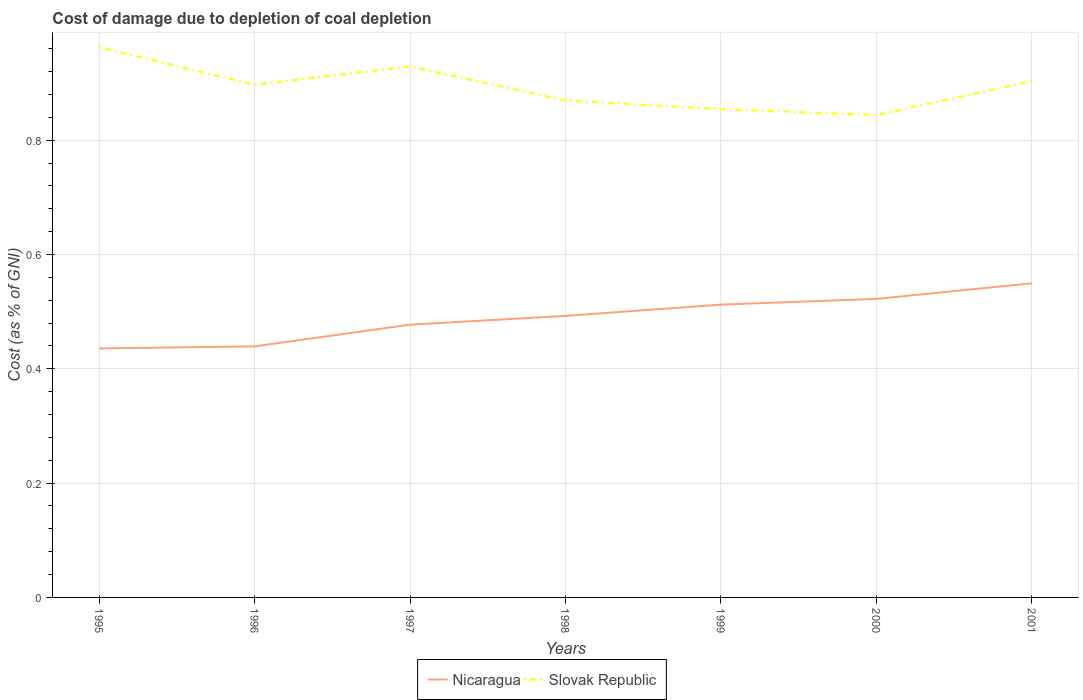Across all years, what is the maximum cost of damage caused due to coal depletion in Nicaragua?
Your response must be concise. 0.44. What is the total cost of damage caused due to coal depletion in Nicaragua in the graph?
Ensure brevity in your answer.  -0.05. What is the difference between the highest and the second highest cost of damage caused due to coal depletion in Nicaragua?
Provide a short and direct response. 0.11. What is the difference between the highest and the lowest cost of damage caused due to coal depletion in Slovak Republic?
Offer a very short reply. 4. Is the cost of damage caused due to coal depletion in Slovak Republic strictly greater than the cost of damage caused due to coal depletion in Nicaragua over the years?
Provide a succinct answer. No. How many lines are there?
Make the answer very short. 2. What is the difference between two consecutive major ticks on the Y-axis?
Offer a very short reply. 0.2. Are the values on the major ticks of Y-axis written in scientific E-notation?
Offer a terse response. No. Does the graph contain any zero values?
Your response must be concise. No. Does the graph contain grids?
Offer a terse response. Yes. What is the title of the graph?
Make the answer very short. Cost of damage due to depletion of coal depletion. Does "Vietnam" appear as one of the legend labels in the graph?
Offer a very short reply. No. What is the label or title of the Y-axis?
Offer a very short reply. Cost (as % of GNI). What is the Cost (as % of GNI) in Nicaragua in 1995?
Your answer should be compact. 0.44. What is the Cost (as % of GNI) in Slovak Republic in 1995?
Your answer should be very brief. 0.96. What is the Cost (as % of GNI) in Nicaragua in 1996?
Ensure brevity in your answer.  0.44. What is the Cost (as % of GNI) in Slovak Republic in 1996?
Give a very brief answer. 0.9. What is the Cost (as % of GNI) in Nicaragua in 1997?
Your response must be concise. 0.48. What is the Cost (as % of GNI) in Slovak Republic in 1997?
Offer a terse response. 0.93. What is the Cost (as % of GNI) in Nicaragua in 1998?
Your response must be concise. 0.49. What is the Cost (as % of GNI) of Slovak Republic in 1998?
Make the answer very short. 0.87. What is the Cost (as % of GNI) in Nicaragua in 1999?
Provide a succinct answer. 0.51. What is the Cost (as % of GNI) in Slovak Republic in 1999?
Your answer should be compact. 0.85. What is the Cost (as % of GNI) in Nicaragua in 2000?
Your answer should be very brief. 0.52. What is the Cost (as % of GNI) of Slovak Republic in 2000?
Offer a very short reply. 0.84. What is the Cost (as % of GNI) in Nicaragua in 2001?
Provide a short and direct response. 0.55. What is the Cost (as % of GNI) in Slovak Republic in 2001?
Provide a short and direct response. 0.9. Across all years, what is the maximum Cost (as % of GNI) in Nicaragua?
Your answer should be very brief. 0.55. Across all years, what is the maximum Cost (as % of GNI) in Slovak Republic?
Your answer should be very brief. 0.96. Across all years, what is the minimum Cost (as % of GNI) in Nicaragua?
Your answer should be compact. 0.44. Across all years, what is the minimum Cost (as % of GNI) of Slovak Republic?
Your response must be concise. 0.84. What is the total Cost (as % of GNI) of Nicaragua in the graph?
Provide a succinct answer. 3.43. What is the total Cost (as % of GNI) in Slovak Republic in the graph?
Your answer should be very brief. 6.26. What is the difference between the Cost (as % of GNI) in Nicaragua in 1995 and that in 1996?
Provide a succinct answer. -0. What is the difference between the Cost (as % of GNI) of Slovak Republic in 1995 and that in 1996?
Your answer should be very brief. 0.07. What is the difference between the Cost (as % of GNI) of Nicaragua in 1995 and that in 1997?
Your answer should be very brief. -0.04. What is the difference between the Cost (as % of GNI) in Slovak Republic in 1995 and that in 1997?
Your answer should be very brief. 0.03. What is the difference between the Cost (as % of GNI) of Nicaragua in 1995 and that in 1998?
Make the answer very short. -0.06. What is the difference between the Cost (as % of GNI) of Slovak Republic in 1995 and that in 1998?
Your response must be concise. 0.09. What is the difference between the Cost (as % of GNI) of Nicaragua in 1995 and that in 1999?
Your answer should be very brief. -0.08. What is the difference between the Cost (as % of GNI) of Slovak Republic in 1995 and that in 1999?
Provide a short and direct response. 0.11. What is the difference between the Cost (as % of GNI) in Nicaragua in 1995 and that in 2000?
Give a very brief answer. -0.09. What is the difference between the Cost (as % of GNI) of Slovak Republic in 1995 and that in 2000?
Offer a very short reply. 0.12. What is the difference between the Cost (as % of GNI) of Nicaragua in 1995 and that in 2001?
Offer a very short reply. -0.11. What is the difference between the Cost (as % of GNI) in Slovak Republic in 1995 and that in 2001?
Provide a short and direct response. 0.06. What is the difference between the Cost (as % of GNI) in Nicaragua in 1996 and that in 1997?
Keep it short and to the point. -0.04. What is the difference between the Cost (as % of GNI) in Slovak Republic in 1996 and that in 1997?
Offer a terse response. -0.03. What is the difference between the Cost (as % of GNI) in Nicaragua in 1996 and that in 1998?
Provide a succinct answer. -0.05. What is the difference between the Cost (as % of GNI) in Slovak Republic in 1996 and that in 1998?
Offer a terse response. 0.03. What is the difference between the Cost (as % of GNI) of Nicaragua in 1996 and that in 1999?
Your answer should be very brief. -0.07. What is the difference between the Cost (as % of GNI) of Slovak Republic in 1996 and that in 1999?
Ensure brevity in your answer.  0.04. What is the difference between the Cost (as % of GNI) of Nicaragua in 1996 and that in 2000?
Make the answer very short. -0.08. What is the difference between the Cost (as % of GNI) of Slovak Republic in 1996 and that in 2000?
Offer a terse response. 0.05. What is the difference between the Cost (as % of GNI) in Nicaragua in 1996 and that in 2001?
Your answer should be very brief. -0.11. What is the difference between the Cost (as % of GNI) of Slovak Republic in 1996 and that in 2001?
Your response must be concise. -0.01. What is the difference between the Cost (as % of GNI) of Nicaragua in 1997 and that in 1998?
Your answer should be very brief. -0.02. What is the difference between the Cost (as % of GNI) in Slovak Republic in 1997 and that in 1998?
Make the answer very short. 0.06. What is the difference between the Cost (as % of GNI) in Nicaragua in 1997 and that in 1999?
Make the answer very short. -0.04. What is the difference between the Cost (as % of GNI) of Slovak Republic in 1997 and that in 1999?
Offer a terse response. 0.07. What is the difference between the Cost (as % of GNI) in Nicaragua in 1997 and that in 2000?
Your answer should be very brief. -0.05. What is the difference between the Cost (as % of GNI) of Slovak Republic in 1997 and that in 2000?
Offer a very short reply. 0.09. What is the difference between the Cost (as % of GNI) of Nicaragua in 1997 and that in 2001?
Offer a very short reply. -0.07. What is the difference between the Cost (as % of GNI) in Slovak Republic in 1997 and that in 2001?
Ensure brevity in your answer.  0.03. What is the difference between the Cost (as % of GNI) of Nicaragua in 1998 and that in 1999?
Make the answer very short. -0.02. What is the difference between the Cost (as % of GNI) in Slovak Republic in 1998 and that in 1999?
Provide a succinct answer. 0.02. What is the difference between the Cost (as % of GNI) of Nicaragua in 1998 and that in 2000?
Offer a terse response. -0.03. What is the difference between the Cost (as % of GNI) of Slovak Republic in 1998 and that in 2000?
Offer a terse response. 0.03. What is the difference between the Cost (as % of GNI) in Nicaragua in 1998 and that in 2001?
Make the answer very short. -0.06. What is the difference between the Cost (as % of GNI) of Slovak Republic in 1998 and that in 2001?
Give a very brief answer. -0.03. What is the difference between the Cost (as % of GNI) of Nicaragua in 1999 and that in 2000?
Ensure brevity in your answer.  -0.01. What is the difference between the Cost (as % of GNI) of Slovak Republic in 1999 and that in 2000?
Offer a terse response. 0.01. What is the difference between the Cost (as % of GNI) in Nicaragua in 1999 and that in 2001?
Keep it short and to the point. -0.04. What is the difference between the Cost (as % of GNI) in Slovak Republic in 1999 and that in 2001?
Offer a terse response. -0.05. What is the difference between the Cost (as % of GNI) in Nicaragua in 2000 and that in 2001?
Your answer should be very brief. -0.03. What is the difference between the Cost (as % of GNI) of Slovak Republic in 2000 and that in 2001?
Your answer should be very brief. -0.06. What is the difference between the Cost (as % of GNI) in Nicaragua in 1995 and the Cost (as % of GNI) in Slovak Republic in 1996?
Offer a very short reply. -0.46. What is the difference between the Cost (as % of GNI) of Nicaragua in 1995 and the Cost (as % of GNI) of Slovak Republic in 1997?
Keep it short and to the point. -0.49. What is the difference between the Cost (as % of GNI) in Nicaragua in 1995 and the Cost (as % of GNI) in Slovak Republic in 1998?
Provide a succinct answer. -0.43. What is the difference between the Cost (as % of GNI) in Nicaragua in 1995 and the Cost (as % of GNI) in Slovak Republic in 1999?
Provide a short and direct response. -0.42. What is the difference between the Cost (as % of GNI) in Nicaragua in 1995 and the Cost (as % of GNI) in Slovak Republic in 2000?
Keep it short and to the point. -0.41. What is the difference between the Cost (as % of GNI) of Nicaragua in 1995 and the Cost (as % of GNI) of Slovak Republic in 2001?
Your response must be concise. -0.47. What is the difference between the Cost (as % of GNI) in Nicaragua in 1996 and the Cost (as % of GNI) in Slovak Republic in 1997?
Make the answer very short. -0.49. What is the difference between the Cost (as % of GNI) of Nicaragua in 1996 and the Cost (as % of GNI) of Slovak Republic in 1998?
Your answer should be very brief. -0.43. What is the difference between the Cost (as % of GNI) in Nicaragua in 1996 and the Cost (as % of GNI) in Slovak Republic in 1999?
Make the answer very short. -0.41. What is the difference between the Cost (as % of GNI) in Nicaragua in 1996 and the Cost (as % of GNI) in Slovak Republic in 2000?
Offer a very short reply. -0.4. What is the difference between the Cost (as % of GNI) of Nicaragua in 1996 and the Cost (as % of GNI) of Slovak Republic in 2001?
Your answer should be very brief. -0.46. What is the difference between the Cost (as % of GNI) of Nicaragua in 1997 and the Cost (as % of GNI) of Slovak Republic in 1998?
Keep it short and to the point. -0.39. What is the difference between the Cost (as % of GNI) of Nicaragua in 1997 and the Cost (as % of GNI) of Slovak Republic in 1999?
Your response must be concise. -0.38. What is the difference between the Cost (as % of GNI) in Nicaragua in 1997 and the Cost (as % of GNI) in Slovak Republic in 2000?
Keep it short and to the point. -0.37. What is the difference between the Cost (as % of GNI) of Nicaragua in 1997 and the Cost (as % of GNI) of Slovak Republic in 2001?
Give a very brief answer. -0.43. What is the difference between the Cost (as % of GNI) in Nicaragua in 1998 and the Cost (as % of GNI) in Slovak Republic in 1999?
Your answer should be very brief. -0.36. What is the difference between the Cost (as % of GNI) in Nicaragua in 1998 and the Cost (as % of GNI) in Slovak Republic in 2000?
Your response must be concise. -0.35. What is the difference between the Cost (as % of GNI) in Nicaragua in 1998 and the Cost (as % of GNI) in Slovak Republic in 2001?
Provide a succinct answer. -0.41. What is the difference between the Cost (as % of GNI) in Nicaragua in 1999 and the Cost (as % of GNI) in Slovak Republic in 2000?
Provide a short and direct response. -0.33. What is the difference between the Cost (as % of GNI) in Nicaragua in 1999 and the Cost (as % of GNI) in Slovak Republic in 2001?
Your response must be concise. -0.39. What is the difference between the Cost (as % of GNI) of Nicaragua in 2000 and the Cost (as % of GNI) of Slovak Republic in 2001?
Make the answer very short. -0.38. What is the average Cost (as % of GNI) in Nicaragua per year?
Give a very brief answer. 0.49. What is the average Cost (as % of GNI) in Slovak Republic per year?
Provide a succinct answer. 0.89. In the year 1995, what is the difference between the Cost (as % of GNI) of Nicaragua and Cost (as % of GNI) of Slovak Republic?
Offer a terse response. -0.53. In the year 1996, what is the difference between the Cost (as % of GNI) in Nicaragua and Cost (as % of GNI) in Slovak Republic?
Keep it short and to the point. -0.46. In the year 1997, what is the difference between the Cost (as % of GNI) of Nicaragua and Cost (as % of GNI) of Slovak Republic?
Offer a terse response. -0.45. In the year 1998, what is the difference between the Cost (as % of GNI) of Nicaragua and Cost (as % of GNI) of Slovak Republic?
Provide a succinct answer. -0.38. In the year 1999, what is the difference between the Cost (as % of GNI) of Nicaragua and Cost (as % of GNI) of Slovak Republic?
Provide a short and direct response. -0.34. In the year 2000, what is the difference between the Cost (as % of GNI) of Nicaragua and Cost (as % of GNI) of Slovak Republic?
Give a very brief answer. -0.32. In the year 2001, what is the difference between the Cost (as % of GNI) in Nicaragua and Cost (as % of GNI) in Slovak Republic?
Make the answer very short. -0.35. What is the ratio of the Cost (as % of GNI) in Nicaragua in 1995 to that in 1996?
Provide a succinct answer. 0.99. What is the ratio of the Cost (as % of GNI) in Slovak Republic in 1995 to that in 1996?
Give a very brief answer. 1.07. What is the ratio of the Cost (as % of GNI) of Nicaragua in 1995 to that in 1997?
Your answer should be very brief. 0.91. What is the ratio of the Cost (as % of GNI) of Slovak Republic in 1995 to that in 1997?
Your answer should be compact. 1.04. What is the ratio of the Cost (as % of GNI) of Nicaragua in 1995 to that in 1998?
Make the answer very short. 0.88. What is the ratio of the Cost (as % of GNI) in Slovak Republic in 1995 to that in 1998?
Your response must be concise. 1.11. What is the ratio of the Cost (as % of GNI) of Nicaragua in 1995 to that in 1999?
Your response must be concise. 0.85. What is the ratio of the Cost (as % of GNI) in Slovak Republic in 1995 to that in 1999?
Offer a terse response. 1.13. What is the ratio of the Cost (as % of GNI) in Nicaragua in 1995 to that in 2000?
Ensure brevity in your answer.  0.83. What is the ratio of the Cost (as % of GNI) of Slovak Republic in 1995 to that in 2000?
Your response must be concise. 1.14. What is the ratio of the Cost (as % of GNI) in Nicaragua in 1995 to that in 2001?
Provide a succinct answer. 0.79. What is the ratio of the Cost (as % of GNI) of Slovak Republic in 1995 to that in 2001?
Your answer should be very brief. 1.07. What is the ratio of the Cost (as % of GNI) in Nicaragua in 1996 to that in 1997?
Provide a succinct answer. 0.92. What is the ratio of the Cost (as % of GNI) of Slovak Republic in 1996 to that in 1997?
Make the answer very short. 0.97. What is the ratio of the Cost (as % of GNI) in Nicaragua in 1996 to that in 1998?
Make the answer very short. 0.89. What is the ratio of the Cost (as % of GNI) in Slovak Republic in 1996 to that in 1998?
Give a very brief answer. 1.03. What is the ratio of the Cost (as % of GNI) of Nicaragua in 1996 to that in 1999?
Your answer should be very brief. 0.86. What is the ratio of the Cost (as % of GNI) of Slovak Republic in 1996 to that in 1999?
Offer a terse response. 1.05. What is the ratio of the Cost (as % of GNI) in Nicaragua in 1996 to that in 2000?
Ensure brevity in your answer.  0.84. What is the ratio of the Cost (as % of GNI) in Slovak Republic in 1996 to that in 2000?
Your answer should be very brief. 1.06. What is the ratio of the Cost (as % of GNI) of Nicaragua in 1996 to that in 2001?
Ensure brevity in your answer.  0.8. What is the ratio of the Cost (as % of GNI) of Slovak Republic in 1996 to that in 2001?
Your answer should be very brief. 0.99. What is the ratio of the Cost (as % of GNI) of Nicaragua in 1997 to that in 1998?
Offer a very short reply. 0.97. What is the ratio of the Cost (as % of GNI) of Slovak Republic in 1997 to that in 1998?
Make the answer very short. 1.07. What is the ratio of the Cost (as % of GNI) of Nicaragua in 1997 to that in 1999?
Your answer should be compact. 0.93. What is the ratio of the Cost (as % of GNI) of Slovak Republic in 1997 to that in 1999?
Give a very brief answer. 1.09. What is the ratio of the Cost (as % of GNI) of Nicaragua in 1997 to that in 2000?
Your answer should be compact. 0.91. What is the ratio of the Cost (as % of GNI) in Slovak Republic in 1997 to that in 2000?
Provide a short and direct response. 1.1. What is the ratio of the Cost (as % of GNI) of Nicaragua in 1997 to that in 2001?
Provide a short and direct response. 0.87. What is the ratio of the Cost (as % of GNI) of Slovak Republic in 1997 to that in 2001?
Make the answer very short. 1.03. What is the ratio of the Cost (as % of GNI) in Nicaragua in 1998 to that in 1999?
Give a very brief answer. 0.96. What is the ratio of the Cost (as % of GNI) of Slovak Republic in 1998 to that in 1999?
Your answer should be compact. 1.02. What is the ratio of the Cost (as % of GNI) in Nicaragua in 1998 to that in 2000?
Keep it short and to the point. 0.94. What is the ratio of the Cost (as % of GNI) of Slovak Republic in 1998 to that in 2000?
Ensure brevity in your answer.  1.03. What is the ratio of the Cost (as % of GNI) of Nicaragua in 1998 to that in 2001?
Offer a terse response. 0.9. What is the ratio of the Cost (as % of GNI) in Slovak Republic in 1998 to that in 2001?
Give a very brief answer. 0.96. What is the ratio of the Cost (as % of GNI) of Nicaragua in 1999 to that in 2000?
Make the answer very short. 0.98. What is the ratio of the Cost (as % of GNI) of Slovak Republic in 1999 to that in 2000?
Offer a terse response. 1.01. What is the ratio of the Cost (as % of GNI) in Nicaragua in 1999 to that in 2001?
Keep it short and to the point. 0.93. What is the ratio of the Cost (as % of GNI) in Slovak Republic in 1999 to that in 2001?
Give a very brief answer. 0.95. What is the ratio of the Cost (as % of GNI) in Nicaragua in 2000 to that in 2001?
Offer a terse response. 0.95. What is the ratio of the Cost (as % of GNI) in Slovak Republic in 2000 to that in 2001?
Offer a very short reply. 0.93. What is the difference between the highest and the second highest Cost (as % of GNI) of Nicaragua?
Provide a succinct answer. 0.03. What is the difference between the highest and the second highest Cost (as % of GNI) of Slovak Republic?
Make the answer very short. 0.03. What is the difference between the highest and the lowest Cost (as % of GNI) of Nicaragua?
Make the answer very short. 0.11. What is the difference between the highest and the lowest Cost (as % of GNI) of Slovak Republic?
Provide a short and direct response. 0.12. 